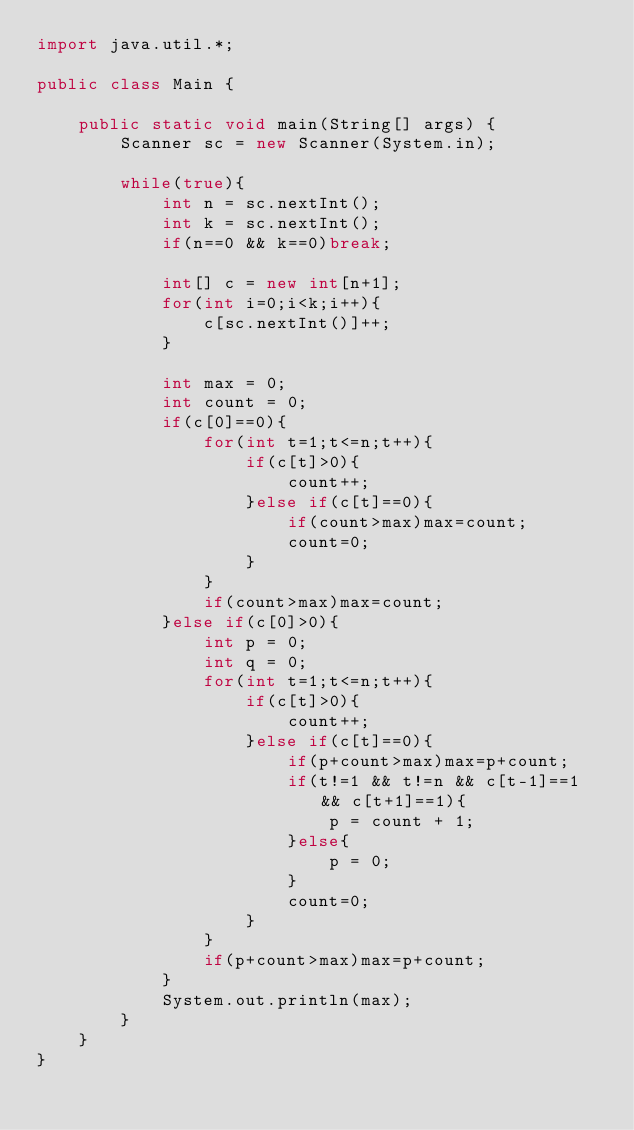Convert code to text. <code><loc_0><loc_0><loc_500><loc_500><_Java_>import java.util.*;

public class Main {
	
	public static void main(String[] args) {
		Scanner sc = new Scanner(System.in);

		while(true){
			int n = sc.nextInt();
			int k = sc.nextInt();
			if(n==0 && k==0)break;
			
			int[] c = new int[n+1];
			for(int i=0;i<k;i++){
				c[sc.nextInt()]++;
			}
			
			int max = 0;
			int count = 0;
			if(c[0]==0){
				for(int t=1;t<=n;t++){
					if(c[t]>0){
						count++;
					}else if(c[t]==0){
						if(count>max)max=count;
						count=0;
					}
				}
				if(count>max)max=count;
			}else if(c[0]>0){
				int p = 0;
				int q = 0;
				for(int t=1;t<=n;t++){
					if(c[t]>0){
						count++;
					}else if(c[t]==0){
						if(p+count>max)max=p+count;
						if(t!=1 && t!=n && c[t-1]==1 && c[t+1]==1){
							p = count + 1;
						}else{
							p = 0;
						}
						count=0;
					}
				}
				if(p+count>max)max=p+count;
			}
			System.out.println(max);		
		}
	}	
}</code> 